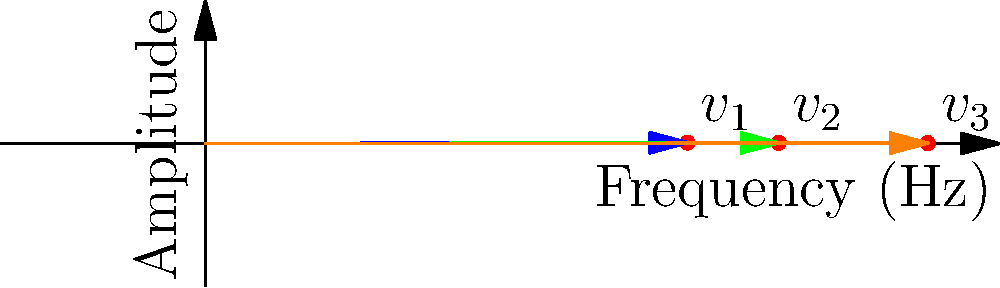In your music production setup, you're working with three musical notes represented as vectors in a frequency-amplitude space. The vectors $v_1$, $v_2$, and $v_3$ correspond to the notes A4, C5, and E5, respectively. Given that $v_1 = (440, 0.8)$, $v_2 = (523.25, 0.6)$, and $v_3 = (659.25, 0.4)$, calculate the magnitude of the resultant vector when these three notes are played simultaneously. Round your answer to two decimal places. To solve this problem, we'll follow these steps:

1) The resultant vector is the sum of the individual vectors: $v_{resultant} = v_1 + v_2 + v_3$

2) To add vectors, we add their components:
   $v_{resultant} = (440 + 523.25 + 659.25, 0.8 + 0.6 + 0.4)$
   $v_{resultant} = (1622.5, 1.8)$

3) To find the magnitude of the resultant vector, we use the Pythagorean theorem:
   $\text{magnitude} = \sqrt{(x_{\text{component}})^2 + (y_{\text{component}})^2}$

4) Substituting our values:
   $\text{magnitude} = \sqrt{(1622.5)^2 + (1.8)^2}$

5) Calculate:
   $\text{magnitude} = \sqrt{2632506.25 + 3.24}$
   $\text{magnitude} = \sqrt{2632509.49}$
   $\text{magnitude} \approx 1622.50$

6) Rounding to two decimal places:
   $\text{magnitude} \approx 1622.50$
Answer: 1622.50 